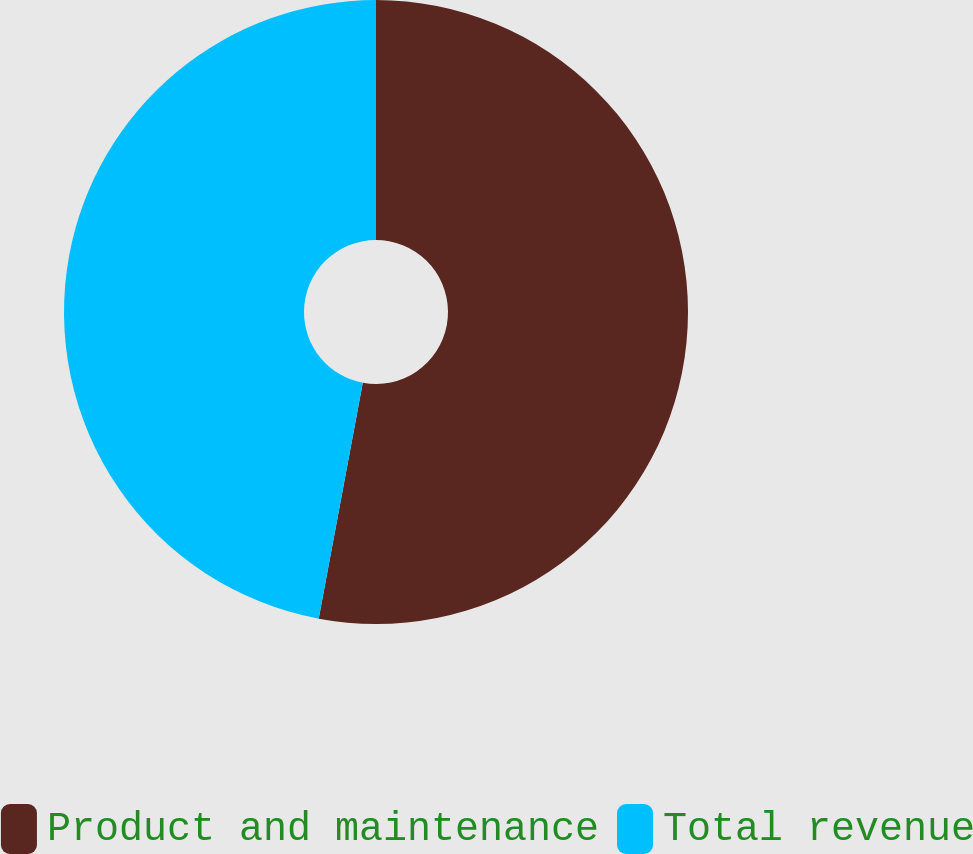Convert chart to OTSL. <chart><loc_0><loc_0><loc_500><loc_500><pie_chart><fcel>Product and maintenance<fcel>Total revenue<nl><fcel>52.94%<fcel>47.06%<nl></chart> 